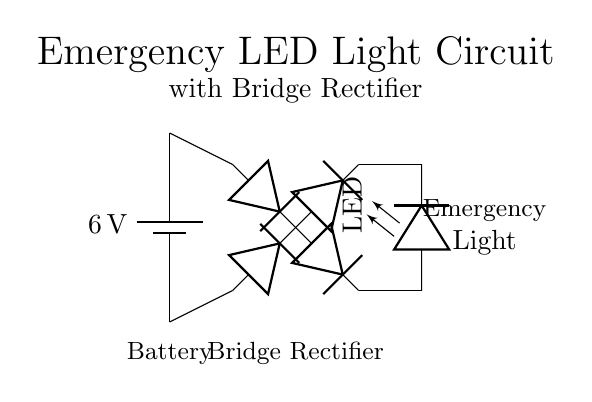What is the voltage of the battery in this circuit? The battery has a label indicating its voltage, which is 6 volts. This means it provides a potential difference of 6 volts in the circuit.
Answer: 6 volts What type of rectifier is used in this circuit? The circuit includes a diagram of a bridge configuration consisting of four diodes arranged in a specific manner to rectify the input voltage. This arrangement is known as a bridge rectifier.
Answer: Bridge rectifier How many diodes are present in the bridge rectifier? By counting the symbols within the bridge rectifier section, there are four distinct diode symbols drawn, indicating the total number of diodes.
Answer: Four What component provides light in this circuit? The circuit has an LED symbol, which represents the light-emitting diode component responsible for producing light when powered.
Answer: LED What is the purpose of the bridge rectifier in this circuit? The bridge rectifier's role is to convert alternating current, which may be inherent in a power source, into direct current that is suitable for the LED to illuminate properly.
Answer: Convert AC to DC What is the function of the battery in this circuit? The battery serves as a power source, supplying electrical energy to the circuit, especially during power outages, allowing the LED to operate.
Answer: Power source 